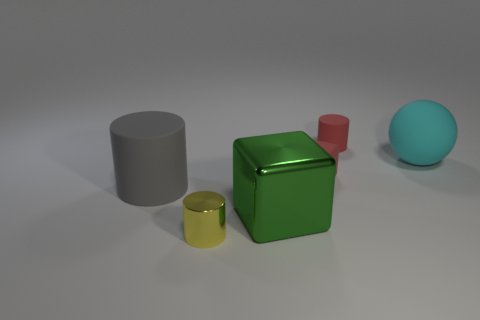Is the material of the gray cylinder the same as the block behind the big gray matte cylinder?
Keep it short and to the point. Yes. How many things are either small metal cylinders or green objects?
Give a very brief answer. 2. What is the material of the small cylinder that is the same color as the small matte block?
Offer a very short reply. Rubber. Is there a small brown matte object that has the same shape as the gray rubber thing?
Offer a terse response. No. What number of rubber things are behind the red matte block?
Your answer should be very brief. 2. There is a object on the left side of the tiny yellow metallic object that is in front of the big metal object; what is it made of?
Ensure brevity in your answer.  Rubber. What material is the green object that is the same size as the cyan thing?
Ensure brevity in your answer.  Metal. Is there a matte cylinder of the same size as the cyan rubber sphere?
Offer a terse response. Yes. There is a small cylinder that is behind the ball; what color is it?
Keep it short and to the point. Red. Is there a large cyan ball that is in front of the big rubber thing that is behind the gray matte object?
Ensure brevity in your answer.  No. 